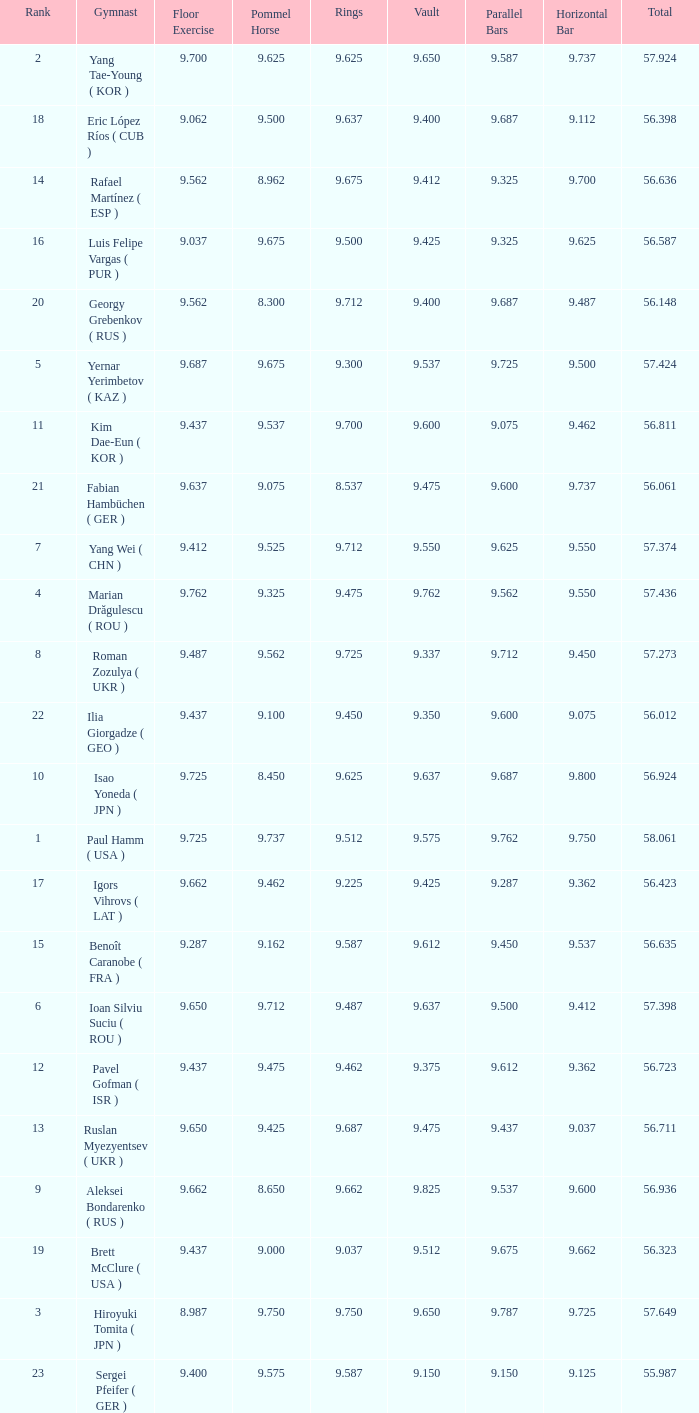What is the total score when the score for floor exercise was 9.287? 56.635. 